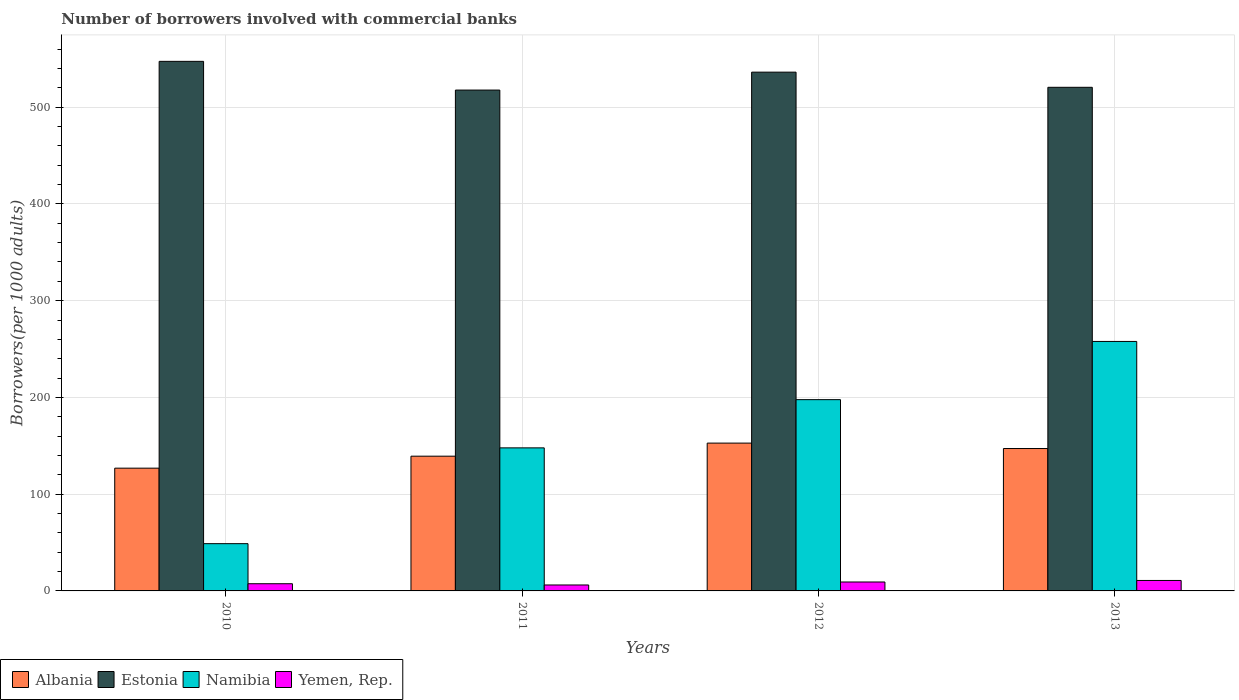How many different coloured bars are there?
Your answer should be very brief. 4. Are the number of bars per tick equal to the number of legend labels?
Make the answer very short. Yes. Are the number of bars on each tick of the X-axis equal?
Your answer should be compact. Yes. How many bars are there on the 2nd tick from the left?
Provide a short and direct response. 4. How many bars are there on the 4th tick from the right?
Ensure brevity in your answer.  4. What is the label of the 2nd group of bars from the left?
Your answer should be very brief. 2011. What is the number of borrowers involved with commercial banks in Albania in 2013?
Give a very brief answer. 147.17. Across all years, what is the maximum number of borrowers involved with commercial banks in Namibia?
Provide a succinct answer. 257.84. Across all years, what is the minimum number of borrowers involved with commercial banks in Namibia?
Provide a succinct answer. 48.85. In which year was the number of borrowers involved with commercial banks in Namibia maximum?
Provide a succinct answer. 2013. In which year was the number of borrowers involved with commercial banks in Yemen, Rep. minimum?
Your answer should be very brief. 2011. What is the total number of borrowers involved with commercial banks in Yemen, Rep. in the graph?
Provide a short and direct response. 33.62. What is the difference between the number of borrowers involved with commercial banks in Albania in 2011 and that in 2013?
Your answer should be compact. -7.91. What is the difference between the number of borrowers involved with commercial banks in Estonia in 2012 and the number of borrowers involved with commercial banks in Albania in 2013?
Provide a short and direct response. 388.98. What is the average number of borrowers involved with commercial banks in Albania per year?
Your response must be concise. 141.52. In the year 2010, what is the difference between the number of borrowers involved with commercial banks in Yemen, Rep. and number of borrowers involved with commercial banks in Estonia?
Ensure brevity in your answer.  -539.89. What is the ratio of the number of borrowers involved with commercial banks in Albania in 2011 to that in 2012?
Ensure brevity in your answer.  0.91. Is the number of borrowers involved with commercial banks in Estonia in 2010 less than that in 2011?
Offer a very short reply. No. What is the difference between the highest and the second highest number of borrowers involved with commercial banks in Yemen, Rep.?
Ensure brevity in your answer.  1.58. What is the difference between the highest and the lowest number of borrowers involved with commercial banks in Namibia?
Your answer should be compact. 208.99. In how many years, is the number of borrowers involved with commercial banks in Yemen, Rep. greater than the average number of borrowers involved with commercial banks in Yemen, Rep. taken over all years?
Ensure brevity in your answer.  2. What does the 3rd bar from the left in 2011 represents?
Your response must be concise. Namibia. What does the 2nd bar from the right in 2013 represents?
Offer a very short reply. Namibia. Is it the case that in every year, the sum of the number of borrowers involved with commercial banks in Albania and number of borrowers involved with commercial banks in Estonia is greater than the number of borrowers involved with commercial banks in Namibia?
Offer a terse response. Yes. How many years are there in the graph?
Your response must be concise. 4. What is the difference between two consecutive major ticks on the Y-axis?
Your answer should be very brief. 100. Does the graph contain grids?
Offer a very short reply. Yes. Where does the legend appear in the graph?
Provide a short and direct response. Bottom left. What is the title of the graph?
Your answer should be very brief. Number of borrowers involved with commercial banks. Does "Lithuania" appear as one of the legend labels in the graph?
Make the answer very short. No. What is the label or title of the X-axis?
Your response must be concise. Years. What is the label or title of the Y-axis?
Make the answer very short. Borrowers(per 1000 adults). What is the Borrowers(per 1000 adults) in Albania in 2010?
Keep it short and to the point. 126.87. What is the Borrowers(per 1000 adults) of Estonia in 2010?
Your answer should be compact. 547.32. What is the Borrowers(per 1000 adults) in Namibia in 2010?
Ensure brevity in your answer.  48.85. What is the Borrowers(per 1000 adults) of Yemen, Rep. in 2010?
Offer a very short reply. 7.43. What is the Borrowers(per 1000 adults) of Albania in 2011?
Provide a short and direct response. 139.27. What is the Borrowers(per 1000 adults) in Estonia in 2011?
Make the answer very short. 517.65. What is the Borrowers(per 1000 adults) in Namibia in 2011?
Ensure brevity in your answer.  147.84. What is the Borrowers(per 1000 adults) of Yemen, Rep. in 2011?
Offer a very short reply. 6.14. What is the Borrowers(per 1000 adults) of Albania in 2012?
Your answer should be compact. 152.78. What is the Borrowers(per 1000 adults) of Estonia in 2012?
Offer a terse response. 536.16. What is the Borrowers(per 1000 adults) in Namibia in 2012?
Your answer should be very brief. 197.69. What is the Borrowers(per 1000 adults) of Yemen, Rep. in 2012?
Provide a short and direct response. 9.23. What is the Borrowers(per 1000 adults) of Albania in 2013?
Make the answer very short. 147.17. What is the Borrowers(per 1000 adults) in Estonia in 2013?
Keep it short and to the point. 520.5. What is the Borrowers(per 1000 adults) of Namibia in 2013?
Provide a succinct answer. 257.84. What is the Borrowers(per 1000 adults) in Yemen, Rep. in 2013?
Make the answer very short. 10.82. Across all years, what is the maximum Borrowers(per 1000 adults) of Albania?
Your response must be concise. 152.78. Across all years, what is the maximum Borrowers(per 1000 adults) in Estonia?
Offer a terse response. 547.32. Across all years, what is the maximum Borrowers(per 1000 adults) of Namibia?
Offer a very short reply. 257.84. Across all years, what is the maximum Borrowers(per 1000 adults) in Yemen, Rep.?
Offer a terse response. 10.82. Across all years, what is the minimum Borrowers(per 1000 adults) in Albania?
Make the answer very short. 126.87. Across all years, what is the minimum Borrowers(per 1000 adults) of Estonia?
Keep it short and to the point. 517.65. Across all years, what is the minimum Borrowers(per 1000 adults) of Namibia?
Provide a short and direct response. 48.85. Across all years, what is the minimum Borrowers(per 1000 adults) in Yemen, Rep.?
Offer a very short reply. 6.14. What is the total Borrowers(per 1000 adults) of Albania in the graph?
Provide a succinct answer. 566.09. What is the total Borrowers(per 1000 adults) of Estonia in the graph?
Your answer should be very brief. 2121.62. What is the total Borrowers(per 1000 adults) in Namibia in the graph?
Keep it short and to the point. 652.22. What is the total Borrowers(per 1000 adults) in Yemen, Rep. in the graph?
Your answer should be very brief. 33.62. What is the difference between the Borrowers(per 1000 adults) in Albania in 2010 and that in 2011?
Provide a short and direct response. -12.4. What is the difference between the Borrowers(per 1000 adults) in Estonia in 2010 and that in 2011?
Offer a terse response. 29.67. What is the difference between the Borrowers(per 1000 adults) in Namibia in 2010 and that in 2011?
Your answer should be compact. -99. What is the difference between the Borrowers(per 1000 adults) in Yemen, Rep. in 2010 and that in 2011?
Offer a terse response. 1.29. What is the difference between the Borrowers(per 1000 adults) of Albania in 2010 and that in 2012?
Provide a short and direct response. -25.91. What is the difference between the Borrowers(per 1000 adults) in Estonia in 2010 and that in 2012?
Provide a short and direct response. 11.16. What is the difference between the Borrowers(per 1000 adults) in Namibia in 2010 and that in 2012?
Your answer should be very brief. -148.84. What is the difference between the Borrowers(per 1000 adults) of Yemen, Rep. in 2010 and that in 2012?
Your response must be concise. -1.8. What is the difference between the Borrowers(per 1000 adults) of Albania in 2010 and that in 2013?
Make the answer very short. -20.31. What is the difference between the Borrowers(per 1000 adults) in Estonia in 2010 and that in 2013?
Provide a short and direct response. 26.82. What is the difference between the Borrowers(per 1000 adults) in Namibia in 2010 and that in 2013?
Your answer should be compact. -208.99. What is the difference between the Borrowers(per 1000 adults) in Yemen, Rep. in 2010 and that in 2013?
Provide a succinct answer. -3.39. What is the difference between the Borrowers(per 1000 adults) of Albania in 2011 and that in 2012?
Give a very brief answer. -13.51. What is the difference between the Borrowers(per 1000 adults) of Estonia in 2011 and that in 2012?
Offer a terse response. -18.51. What is the difference between the Borrowers(per 1000 adults) of Namibia in 2011 and that in 2012?
Offer a terse response. -49.85. What is the difference between the Borrowers(per 1000 adults) in Yemen, Rep. in 2011 and that in 2012?
Provide a short and direct response. -3.09. What is the difference between the Borrowers(per 1000 adults) of Albania in 2011 and that in 2013?
Make the answer very short. -7.91. What is the difference between the Borrowers(per 1000 adults) in Estonia in 2011 and that in 2013?
Give a very brief answer. -2.85. What is the difference between the Borrowers(per 1000 adults) in Namibia in 2011 and that in 2013?
Make the answer very short. -110. What is the difference between the Borrowers(per 1000 adults) of Yemen, Rep. in 2011 and that in 2013?
Your response must be concise. -4.67. What is the difference between the Borrowers(per 1000 adults) in Albania in 2012 and that in 2013?
Ensure brevity in your answer.  5.61. What is the difference between the Borrowers(per 1000 adults) of Estonia in 2012 and that in 2013?
Your answer should be compact. 15.66. What is the difference between the Borrowers(per 1000 adults) of Namibia in 2012 and that in 2013?
Provide a succinct answer. -60.15. What is the difference between the Borrowers(per 1000 adults) in Yemen, Rep. in 2012 and that in 2013?
Offer a terse response. -1.58. What is the difference between the Borrowers(per 1000 adults) in Albania in 2010 and the Borrowers(per 1000 adults) in Estonia in 2011?
Make the answer very short. -390.78. What is the difference between the Borrowers(per 1000 adults) in Albania in 2010 and the Borrowers(per 1000 adults) in Namibia in 2011?
Provide a short and direct response. -20.98. What is the difference between the Borrowers(per 1000 adults) of Albania in 2010 and the Borrowers(per 1000 adults) of Yemen, Rep. in 2011?
Offer a very short reply. 120.72. What is the difference between the Borrowers(per 1000 adults) of Estonia in 2010 and the Borrowers(per 1000 adults) of Namibia in 2011?
Your answer should be compact. 399.48. What is the difference between the Borrowers(per 1000 adults) in Estonia in 2010 and the Borrowers(per 1000 adults) in Yemen, Rep. in 2011?
Your response must be concise. 541.18. What is the difference between the Borrowers(per 1000 adults) in Namibia in 2010 and the Borrowers(per 1000 adults) in Yemen, Rep. in 2011?
Give a very brief answer. 42.7. What is the difference between the Borrowers(per 1000 adults) of Albania in 2010 and the Borrowers(per 1000 adults) of Estonia in 2012?
Your answer should be compact. -409.29. What is the difference between the Borrowers(per 1000 adults) of Albania in 2010 and the Borrowers(per 1000 adults) of Namibia in 2012?
Give a very brief answer. -70.82. What is the difference between the Borrowers(per 1000 adults) of Albania in 2010 and the Borrowers(per 1000 adults) of Yemen, Rep. in 2012?
Make the answer very short. 117.63. What is the difference between the Borrowers(per 1000 adults) in Estonia in 2010 and the Borrowers(per 1000 adults) in Namibia in 2012?
Your answer should be compact. 349.63. What is the difference between the Borrowers(per 1000 adults) of Estonia in 2010 and the Borrowers(per 1000 adults) of Yemen, Rep. in 2012?
Your answer should be very brief. 538.09. What is the difference between the Borrowers(per 1000 adults) of Namibia in 2010 and the Borrowers(per 1000 adults) of Yemen, Rep. in 2012?
Provide a succinct answer. 39.61. What is the difference between the Borrowers(per 1000 adults) of Albania in 2010 and the Borrowers(per 1000 adults) of Estonia in 2013?
Your response must be concise. -393.63. What is the difference between the Borrowers(per 1000 adults) in Albania in 2010 and the Borrowers(per 1000 adults) in Namibia in 2013?
Provide a short and direct response. -130.98. What is the difference between the Borrowers(per 1000 adults) in Albania in 2010 and the Borrowers(per 1000 adults) in Yemen, Rep. in 2013?
Your response must be concise. 116.05. What is the difference between the Borrowers(per 1000 adults) in Estonia in 2010 and the Borrowers(per 1000 adults) in Namibia in 2013?
Provide a succinct answer. 289.48. What is the difference between the Borrowers(per 1000 adults) in Estonia in 2010 and the Borrowers(per 1000 adults) in Yemen, Rep. in 2013?
Your response must be concise. 536.5. What is the difference between the Borrowers(per 1000 adults) of Namibia in 2010 and the Borrowers(per 1000 adults) of Yemen, Rep. in 2013?
Keep it short and to the point. 38.03. What is the difference between the Borrowers(per 1000 adults) of Albania in 2011 and the Borrowers(per 1000 adults) of Estonia in 2012?
Your response must be concise. -396.89. What is the difference between the Borrowers(per 1000 adults) in Albania in 2011 and the Borrowers(per 1000 adults) in Namibia in 2012?
Your response must be concise. -58.42. What is the difference between the Borrowers(per 1000 adults) of Albania in 2011 and the Borrowers(per 1000 adults) of Yemen, Rep. in 2012?
Offer a terse response. 130.03. What is the difference between the Borrowers(per 1000 adults) of Estonia in 2011 and the Borrowers(per 1000 adults) of Namibia in 2012?
Make the answer very short. 319.96. What is the difference between the Borrowers(per 1000 adults) in Estonia in 2011 and the Borrowers(per 1000 adults) in Yemen, Rep. in 2012?
Make the answer very short. 508.42. What is the difference between the Borrowers(per 1000 adults) in Namibia in 2011 and the Borrowers(per 1000 adults) in Yemen, Rep. in 2012?
Keep it short and to the point. 138.61. What is the difference between the Borrowers(per 1000 adults) in Albania in 2011 and the Borrowers(per 1000 adults) in Estonia in 2013?
Keep it short and to the point. -381.23. What is the difference between the Borrowers(per 1000 adults) in Albania in 2011 and the Borrowers(per 1000 adults) in Namibia in 2013?
Provide a succinct answer. -118.58. What is the difference between the Borrowers(per 1000 adults) of Albania in 2011 and the Borrowers(per 1000 adults) of Yemen, Rep. in 2013?
Provide a succinct answer. 128.45. What is the difference between the Borrowers(per 1000 adults) of Estonia in 2011 and the Borrowers(per 1000 adults) of Namibia in 2013?
Provide a short and direct response. 259.81. What is the difference between the Borrowers(per 1000 adults) in Estonia in 2011 and the Borrowers(per 1000 adults) in Yemen, Rep. in 2013?
Provide a succinct answer. 506.83. What is the difference between the Borrowers(per 1000 adults) of Namibia in 2011 and the Borrowers(per 1000 adults) of Yemen, Rep. in 2013?
Keep it short and to the point. 137.03. What is the difference between the Borrowers(per 1000 adults) of Albania in 2012 and the Borrowers(per 1000 adults) of Estonia in 2013?
Your answer should be very brief. -367.72. What is the difference between the Borrowers(per 1000 adults) of Albania in 2012 and the Borrowers(per 1000 adults) of Namibia in 2013?
Ensure brevity in your answer.  -105.06. What is the difference between the Borrowers(per 1000 adults) of Albania in 2012 and the Borrowers(per 1000 adults) of Yemen, Rep. in 2013?
Your answer should be compact. 141.96. What is the difference between the Borrowers(per 1000 adults) of Estonia in 2012 and the Borrowers(per 1000 adults) of Namibia in 2013?
Give a very brief answer. 278.32. What is the difference between the Borrowers(per 1000 adults) in Estonia in 2012 and the Borrowers(per 1000 adults) in Yemen, Rep. in 2013?
Provide a succinct answer. 525.34. What is the difference between the Borrowers(per 1000 adults) in Namibia in 2012 and the Borrowers(per 1000 adults) in Yemen, Rep. in 2013?
Your response must be concise. 186.87. What is the average Borrowers(per 1000 adults) in Albania per year?
Provide a succinct answer. 141.52. What is the average Borrowers(per 1000 adults) of Estonia per year?
Your answer should be very brief. 530.41. What is the average Borrowers(per 1000 adults) in Namibia per year?
Your answer should be very brief. 163.06. What is the average Borrowers(per 1000 adults) in Yemen, Rep. per year?
Your answer should be compact. 8.41. In the year 2010, what is the difference between the Borrowers(per 1000 adults) of Albania and Borrowers(per 1000 adults) of Estonia?
Make the answer very short. -420.45. In the year 2010, what is the difference between the Borrowers(per 1000 adults) in Albania and Borrowers(per 1000 adults) in Namibia?
Ensure brevity in your answer.  78.02. In the year 2010, what is the difference between the Borrowers(per 1000 adults) of Albania and Borrowers(per 1000 adults) of Yemen, Rep.?
Provide a short and direct response. 119.44. In the year 2010, what is the difference between the Borrowers(per 1000 adults) of Estonia and Borrowers(per 1000 adults) of Namibia?
Keep it short and to the point. 498.47. In the year 2010, what is the difference between the Borrowers(per 1000 adults) of Estonia and Borrowers(per 1000 adults) of Yemen, Rep.?
Your response must be concise. 539.89. In the year 2010, what is the difference between the Borrowers(per 1000 adults) in Namibia and Borrowers(per 1000 adults) in Yemen, Rep.?
Your response must be concise. 41.42. In the year 2011, what is the difference between the Borrowers(per 1000 adults) of Albania and Borrowers(per 1000 adults) of Estonia?
Provide a short and direct response. -378.38. In the year 2011, what is the difference between the Borrowers(per 1000 adults) in Albania and Borrowers(per 1000 adults) in Namibia?
Give a very brief answer. -8.58. In the year 2011, what is the difference between the Borrowers(per 1000 adults) of Albania and Borrowers(per 1000 adults) of Yemen, Rep.?
Make the answer very short. 133.12. In the year 2011, what is the difference between the Borrowers(per 1000 adults) in Estonia and Borrowers(per 1000 adults) in Namibia?
Give a very brief answer. 369.8. In the year 2011, what is the difference between the Borrowers(per 1000 adults) of Estonia and Borrowers(per 1000 adults) of Yemen, Rep.?
Provide a succinct answer. 511.5. In the year 2011, what is the difference between the Borrowers(per 1000 adults) of Namibia and Borrowers(per 1000 adults) of Yemen, Rep.?
Provide a succinct answer. 141.7. In the year 2012, what is the difference between the Borrowers(per 1000 adults) in Albania and Borrowers(per 1000 adults) in Estonia?
Your answer should be very brief. -383.38. In the year 2012, what is the difference between the Borrowers(per 1000 adults) in Albania and Borrowers(per 1000 adults) in Namibia?
Provide a short and direct response. -44.91. In the year 2012, what is the difference between the Borrowers(per 1000 adults) of Albania and Borrowers(per 1000 adults) of Yemen, Rep.?
Your answer should be compact. 143.55. In the year 2012, what is the difference between the Borrowers(per 1000 adults) of Estonia and Borrowers(per 1000 adults) of Namibia?
Provide a succinct answer. 338.47. In the year 2012, what is the difference between the Borrowers(per 1000 adults) of Estonia and Borrowers(per 1000 adults) of Yemen, Rep.?
Ensure brevity in your answer.  526.93. In the year 2012, what is the difference between the Borrowers(per 1000 adults) of Namibia and Borrowers(per 1000 adults) of Yemen, Rep.?
Your answer should be compact. 188.46. In the year 2013, what is the difference between the Borrowers(per 1000 adults) in Albania and Borrowers(per 1000 adults) in Estonia?
Provide a succinct answer. -373.32. In the year 2013, what is the difference between the Borrowers(per 1000 adults) in Albania and Borrowers(per 1000 adults) in Namibia?
Keep it short and to the point. -110.67. In the year 2013, what is the difference between the Borrowers(per 1000 adults) in Albania and Borrowers(per 1000 adults) in Yemen, Rep.?
Keep it short and to the point. 136.36. In the year 2013, what is the difference between the Borrowers(per 1000 adults) of Estonia and Borrowers(per 1000 adults) of Namibia?
Your response must be concise. 262.66. In the year 2013, what is the difference between the Borrowers(per 1000 adults) of Estonia and Borrowers(per 1000 adults) of Yemen, Rep.?
Make the answer very short. 509.68. In the year 2013, what is the difference between the Borrowers(per 1000 adults) in Namibia and Borrowers(per 1000 adults) in Yemen, Rep.?
Ensure brevity in your answer.  247.03. What is the ratio of the Borrowers(per 1000 adults) in Albania in 2010 to that in 2011?
Offer a terse response. 0.91. What is the ratio of the Borrowers(per 1000 adults) in Estonia in 2010 to that in 2011?
Give a very brief answer. 1.06. What is the ratio of the Borrowers(per 1000 adults) of Namibia in 2010 to that in 2011?
Ensure brevity in your answer.  0.33. What is the ratio of the Borrowers(per 1000 adults) of Yemen, Rep. in 2010 to that in 2011?
Your answer should be very brief. 1.21. What is the ratio of the Borrowers(per 1000 adults) in Albania in 2010 to that in 2012?
Offer a terse response. 0.83. What is the ratio of the Borrowers(per 1000 adults) in Estonia in 2010 to that in 2012?
Provide a succinct answer. 1.02. What is the ratio of the Borrowers(per 1000 adults) of Namibia in 2010 to that in 2012?
Provide a short and direct response. 0.25. What is the ratio of the Borrowers(per 1000 adults) in Yemen, Rep. in 2010 to that in 2012?
Ensure brevity in your answer.  0.8. What is the ratio of the Borrowers(per 1000 adults) of Albania in 2010 to that in 2013?
Provide a succinct answer. 0.86. What is the ratio of the Borrowers(per 1000 adults) of Estonia in 2010 to that in 2013?
Ensure brevity in your answer.  1.05. What is the ratio of the Borrowers(per 1000 adults) of Namibia in 2010 to that in 2013?
Give a very brief answer. 0.19. What is the ratio of the Borrowers(per 1000 adults) in Yemen, Rep. in 2010 to that in 2013?
Ensure brevity in your answer.  0.69. What is the ratio of the Borrowers(per 1000 adults) of Albania in 2011 to that in 2012?
Your answer should be very brief. 0.91. What is the ratio of the Borrowers(per 1000 adults) of Estonia in 2011 to that in 2012?
Offer a very short reply. 0.97. What is the ratio of the Borrowers(per 1000 adults) of Namibia in 2011 to that in 2012?
Ensure brevity in your answer.  0.75. What is the ratio of the Borrowers(per 1000 adults) of Yemen, Rep. in 2011 to that in 2012?
Give a very brief answer. 0.67. What is the ratio of the Borrowers(per 1000 adults) in Albania in 2011 to that in 2013?
Make the answer very short. 0.95. What is the ratio of the Borrowers(per 1000 adults) of Estonia in 2011 to that in 2013?
Offer a very short reply. 0.99. What is the ratio of the Borrowers(per 1000 adults) of Namibia in 2011 to that in 2013?
Keep it short and to the point. 0.57. What is the ratio of the Borrowers(per 1000 adults) of Yemen, Rep. in 2011 to that in 2013?
Keep it short and to the point. 0.57. What is the ratio of the Borrowers(per 1000 adults) of Albania in 2012 to that in 2013?
Keep it short and to the point. 1.04. What is the ratio of the Borrowers(per 1000 adults) in Estonia in 2012 to that in 2013?
Your answer should be very brief. 1.03. What is the ratio of the Borrowers(per 1000 adults) in Namibia in 2012 to that in 2013?
Ensure brevity in your answer.  0.77. What is the ratio of the Borrowers(per 1000 adults) of Yemen, Rep. in 2012 to that in 2013?
Make the answer very short. 0.85. What is the difference between the highest and the second highest Borrowers(per 1000 adults) of Albania?
Ensure brevity in your answer.  5.61. What is the difference between the highest and the second highest Borrowers(per 1000 adults) of Estonia?
Offer a very short reply. 11.16. What is the difference between the highest and the second highest Borrowers(per 1000 adults) in Namibia?
Make the answer very short. 60.15. What is the difference between the highest and the second highest Borrowers(per 1000 adults) in Yemen, Rep.?
Your answer should be compact. 1.58. What is the difference between the highest and the lowest Borrowers(per 1000 adults) of Albania?
Make the answer very short. 25.91. What is the difference between the highest and the lowest Borrowers(per 1000 adults) of Estonia?
Your answer should be compact. 29.67. What is the difference between the highest and the lowest Borrowers(per 1000 adults) of Namibia?
Your answer should be compact. 208.99. What is the difference between the highest and the lowest Borrowers(per 1000 adults) of Yemen, Rep.?
Give a very brief answer. 4.67. 